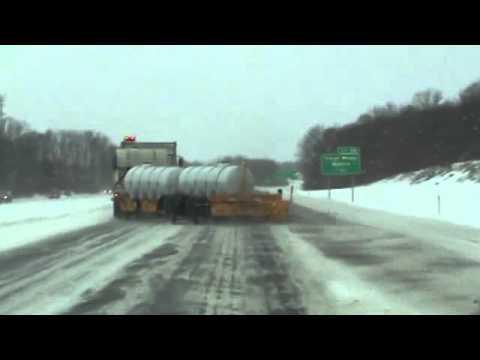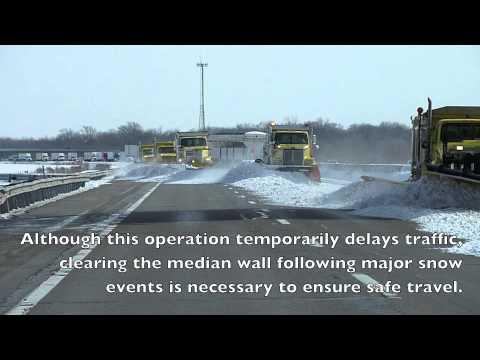The first image is the image on the left, the second image is the image on the right. Evaluate the accuracy of this statement regarding the images: "Both images show at least one camera-facing tow plow truck with a yellow cab, clearing a snowy road.". Is it true? Answer yes or no. No. 